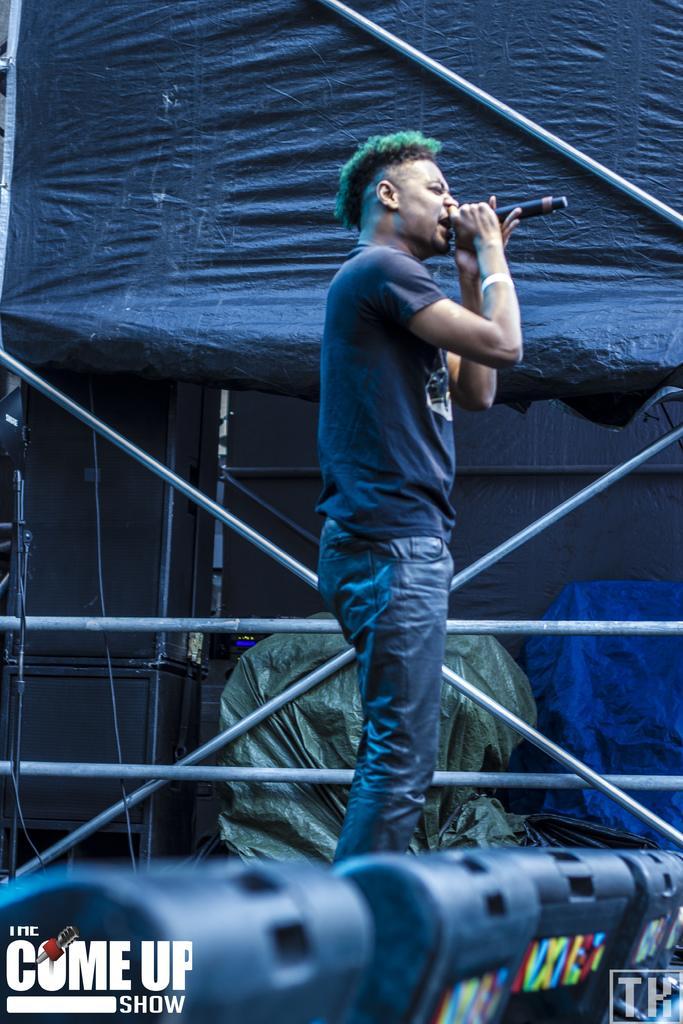Describe this image in one or two sentences. There is a person holding a mic and singing. In the back there are rods. In the background there is a sheet. Some items are covered with sheets. At the bottom there are some objects. Also something is written in the bottom corners. 